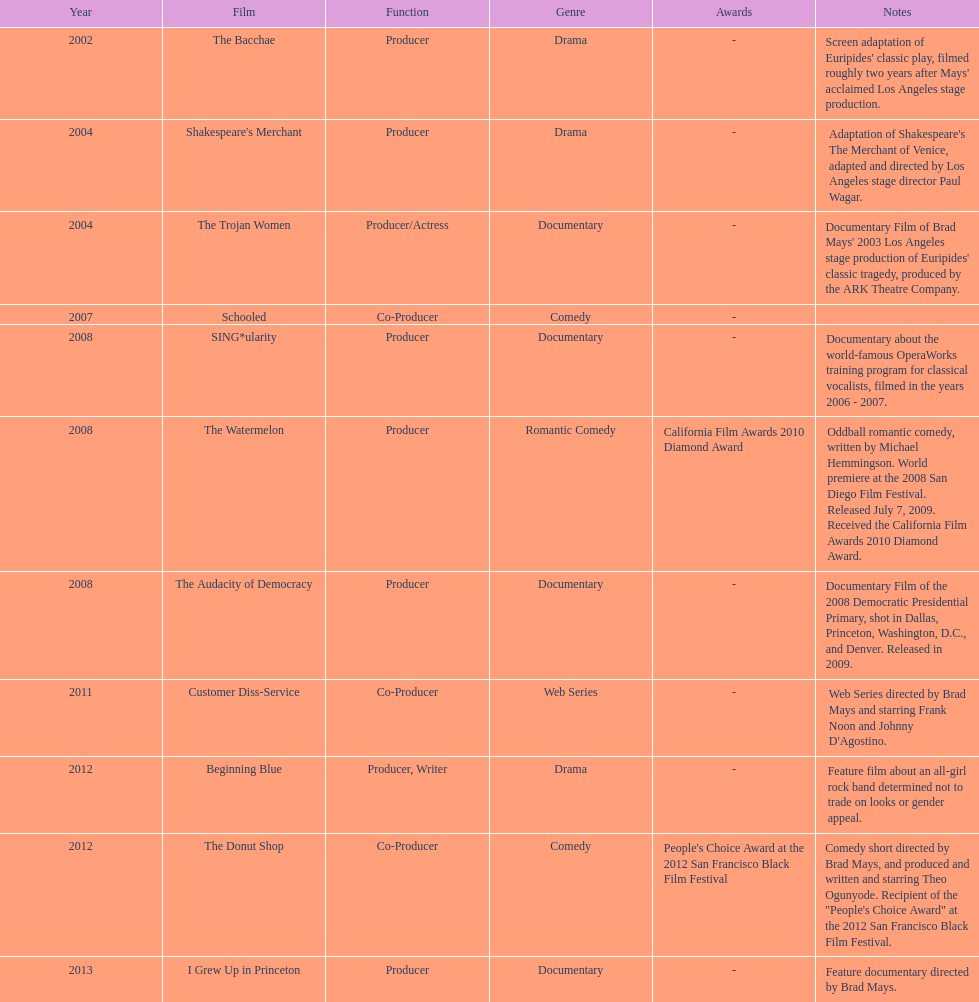How long was the film schooled out before beginning blue? 5 years. 